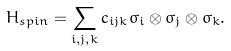Convert formula to latex. <formula><loc_0><loc_0><loc_500><loc_500>H _ { s p i n } = \sum _ { i , j , k } c _ { i j k } \sigma _ { i } \otimes \sigma _ { j } \otimes \sigma _ { k } .</formula> 